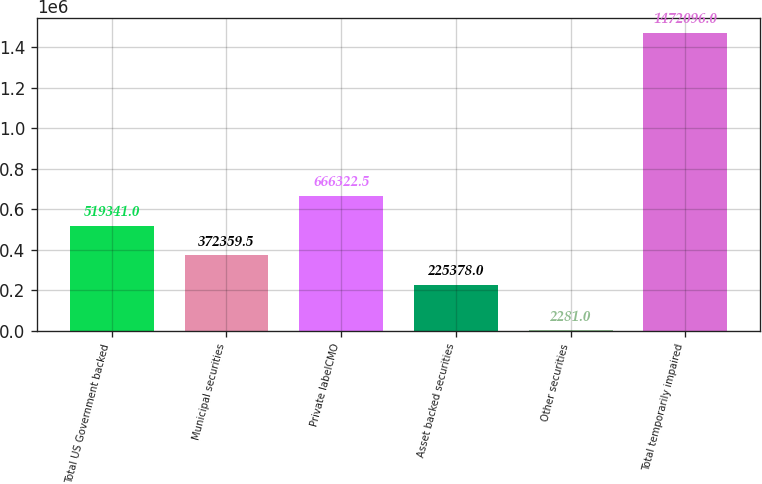Convert chart to OTSL. <chart><loc_0><loc_0><loc_500><loc_500><bar_chart><fcel>Total US Government backed<fcel>Municipal securities<fcel>Private labelCMO<fcel>Asset backed securities<fcel>Other securities<fcel>Total temporarily impaired<nl><fcel>519341<fcel>372360<fcel>666322<fcel>225378<fcel>2281<fcel>1.4721e+06<nl></chart> 